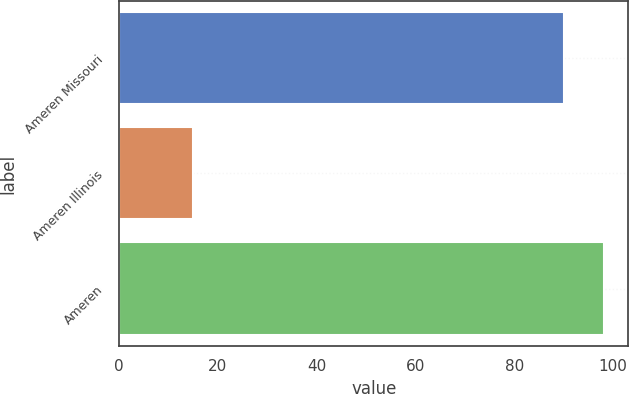Convert chart to OTSL. <chart><loc_0><loc_0><loc_500><loc_500><bar_chart><fcel>Ameren Missouri<fcel>Ameren Illinois<fcel>Ameren<nl><fcel>90<fcel>15<fcel>98.2<nl></chart> 